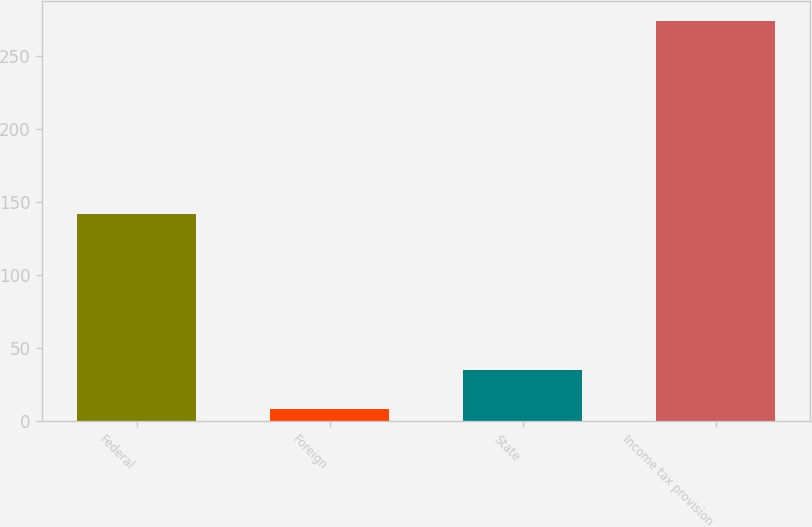<chart> <loc_0><loc_0><loc_500><loc_500><bar_chart><fcel>Federal<fcel>Foreign<fcel>State<fcel>Income tax provision<nl><fcel>141.7<fcel>8.6<fcel>35.11<fcel>273.7<nl></chart> 